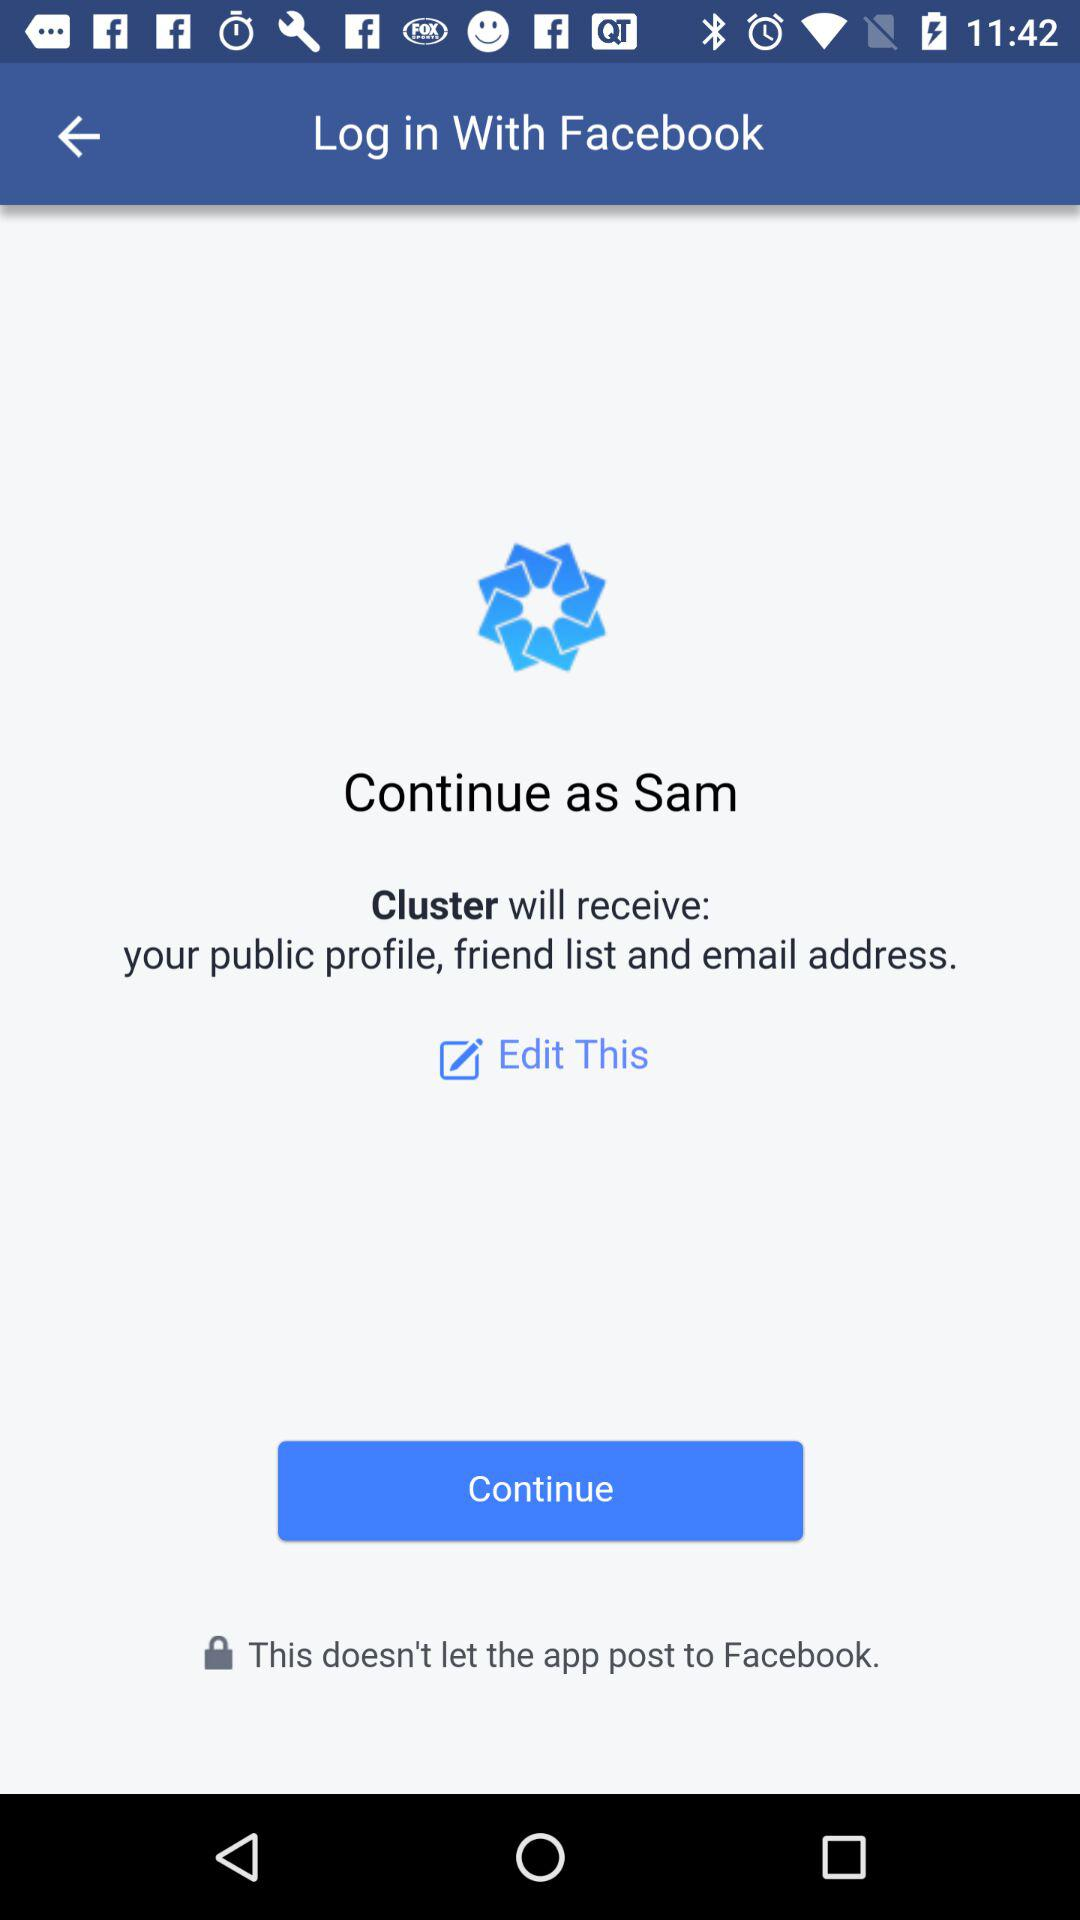What application is asking for permission? The application "Cluster" is asking for permission. 